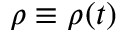<formula> <loc_0><loc_0><loc_500><loc_500>\rho \equiv \rho ( t )</formula> 